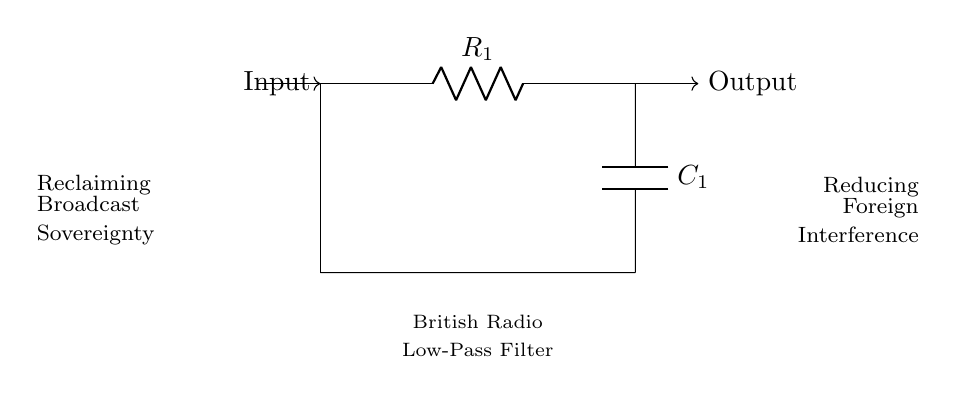What components are present in this filter circuit? The circuit diagram includes a resistor and a capacitor, identified as R1 and C1, respectively.
Answer: Resistor and capacitor What is the function of the resistor in this low-pass filter? The resistor limits the amount of signal current flowing through the circuit, which helps in filtering high-frequency signals.
Answer: Limits current What is the primary purpose of this low-pass filter? The low-pass filter is designed to pass low-frequency signals while attenuating or blocking high-frequency interference, particularly in British radio broadcasts.
Answer: Reducing interference How does the capacitor affect the frequency response of the filter? The capacitor allows lower frequency signals to pass while blocking higher frequency signals, causing the filter to have a cutoff frequency.
Answer: Blocks high frequencies What do the arrows labeled 'Input' and 'Output' indicate? The arrows indicate the direction of signal flow in the circuit; the signal enters at the 'Input' and exits at the 'Output' after processing through the filter.
Answer: Signal flow direction What does the label 'British Radio Low-Pass Filter' signify? This label identifies the specific application of the circuit, indicating that it is a low-pass filter designed for use in British radio broadcasts.
Answer: Specific application 